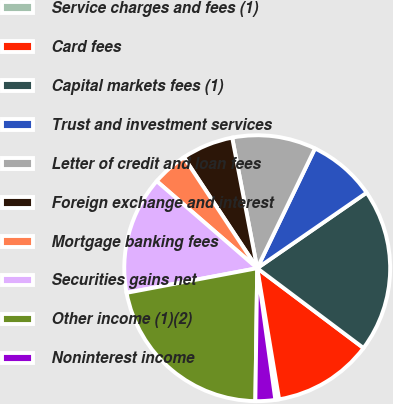<chart> <loc_0><loc_0><loc_500><loc_500><pie_chart><fcel>Service charges and fees (1)<fcel>Card fees<fcel>Capital markets fees (1)<fcel>Trust and investment services<fcel>Letter of credit and loan fees<fcel>Foreign exchange and interest<fcel>Mortgage banking fees<fcel>Securities gains net<fcel>Other income (1)(2)<fcel>Noninterest income<nl><fcel>0.46%<fcel>12.11%<fcel>19.87%<fcel>8.23%<fcel>10.17%<fcel>6.28%<fcel>4.34%<fcel>14.33%<fcel>21.81%<fcel>2.4%<nl></chart> 